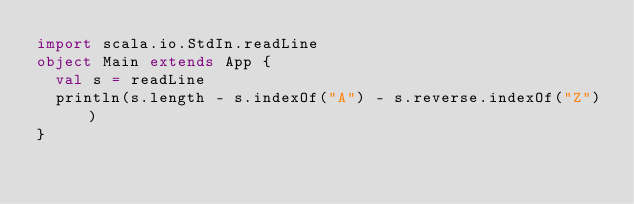Convert code to text. <code><loc_0><loc_0><loc_500><loc_500><_Scala_>import scala.io.StdIn.readLine
object Main extends App {
  val s = readLine
  println(s.length - s.indexOf("A") - s.reverse.indexOf("Z"))
}
</code> 